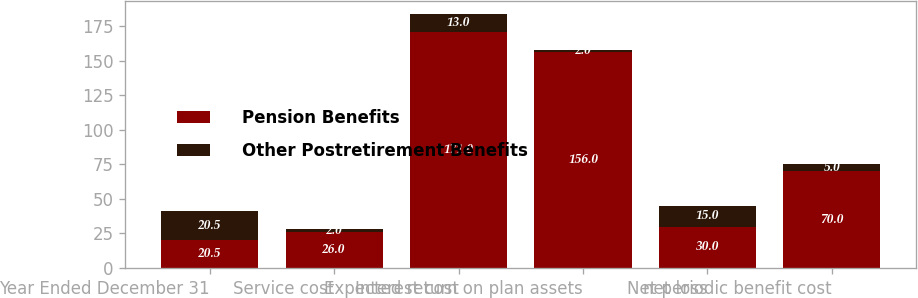Convert chart to OTSL. <chart><loc_0><loc_0><loc_500><loc_500><stacked_bar_chart><ecel><fcel>Year Ended December 31<fcel>Service cost<fcel>Interest cost<fcel>Expected return on plan assets<fcel>net loss<fcel>Net periodic benefit cost<nl><fcel>Pension Benefits<fcel>20.5<fcel>26<fcel>171<fcel>156<fcel>30<fcel>70<nl><fcel>Other Postretirement Benefits<fcel>20.5<fcel>2<fcel>13<fcel>2<fcel>15<fcel>5<nl></chart> 